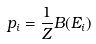<formula> <loc_0><loc_0><loc_500><loc_500>p _ { i } = \frac { 1 } { Z } B ( E _ { i } )</formula> 